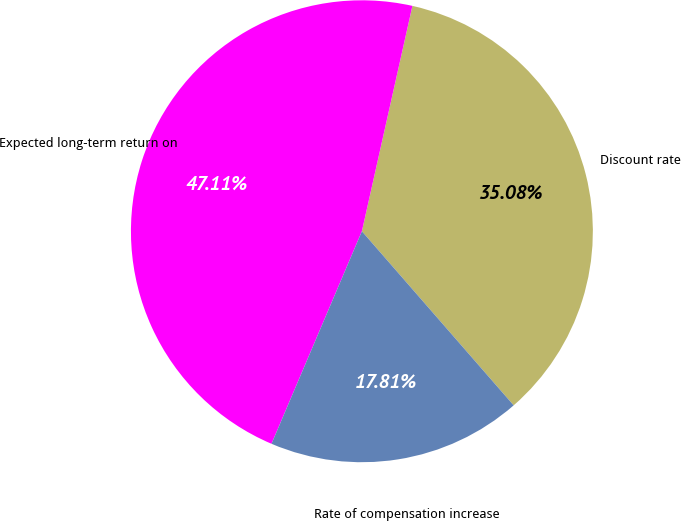<chart> <loc_0><loc_0><loc_500><loc_500><pie_chart><fcel>Discount rate<fcel>Expected long-term return on<fcel>Rate of compensation increase<nl><fcel>35.08%<fcel>47.11%<fcel>17.81%<nl></chart> 